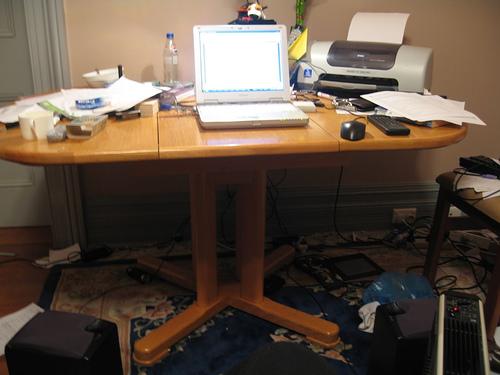What type of rug is on the floor?
Quick response, please. Oriental. Is this area messy?
Short answer required. Yes. Is this an office for multiple people?
Answer briefly. No. How many water bottles are there?
Concise answer only. 1. What color is the computer monitor?
Answer briefly. White. What color is the chair?
Give a very brief answer. Brown. Where is the printer?
Short answer required. On table. How many monitor is there?
Concise answer only. 1. How many computers are shown?
Give a very brief answer. 1. What color is the laptop?
Concise answer only. White. Is the computer a laptop or desktop?
Answer briefly. Laptop. 